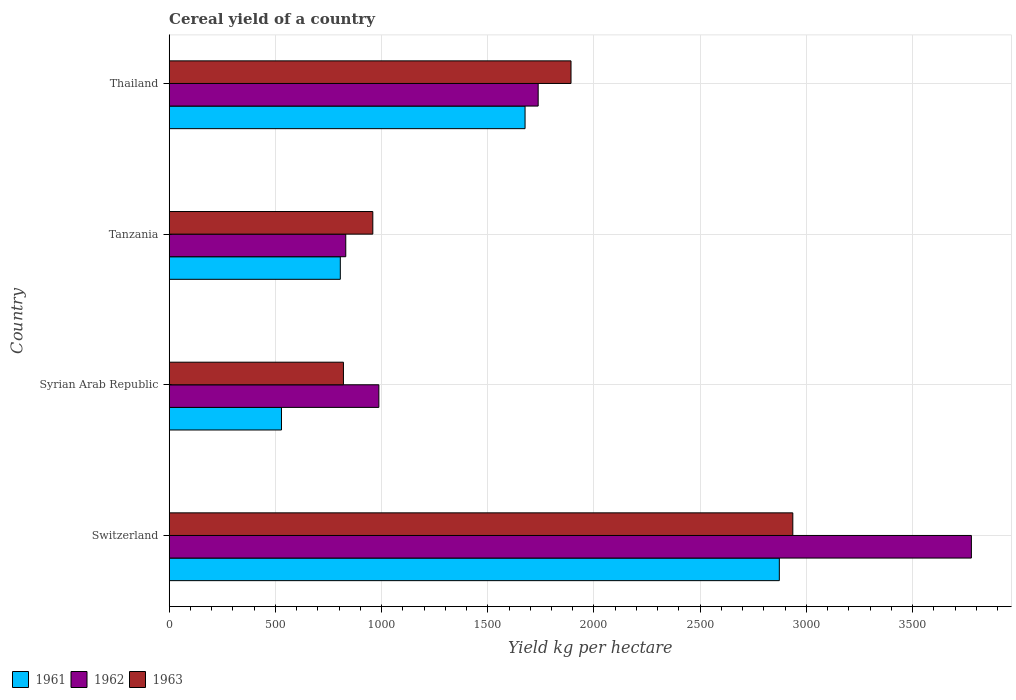How many groups of bars are there?
Provide a short and direct response. 4. Are the number of bars per tick equal to the number of legend labels?
Provide a short and direct response. Yes. Are the number of bars on each tick of the Y-axis equal?
Give a very brief answer. Yes. How many bars are there on the 3rd tick from the bottom?
Provide a short and direct response. 3. What is the label of the 4th group of bars from the top?
Keep it short and to the point. Switzerland. In how many cases, is the number of bars for a given country not equal to the number of legend labels?
Keep it short and to the point. 0. What is the total cereal yield in 1961 in Syrian Arab Republic?
Provide a short and direct response. 528.63. Across all countries, what is the maximum total cereal yield in 1961?
Your answer should be very brief. 2872.6. Across all countries, what is the minimum total cereal yield in 1963?
Make the answer very short. 820.32. In which country was the total cereal yield in 1963 maximum?
Keep it short and to the point. Switzerland. In which country was the total cereal yield in 1963 minimum?
Provide a short and direct response. Syrian Arab Republic. What is the total total cereal yield in 1962 in the graph?
Provide a short and direct response. 7332.44. What is the difference between the total cereal yield in 1963 in Syrian Arab Republic and that in Thailand?
Offer a very short reply. -1071.49. What is the difference between the total cereal yield in 1961 in Syrian Arab Republic and the total cereal yield in 1963 in Tanzania?
Make the answer very short. -430.02. What is the average total cereal yield in 1963 per country?
Your response must be concise. 1651.72. What is the difference between the total cereal yield in 1961 and total cereal yield in 1963 in Tanzania?
Offer a very short reply. -152.99. In how many countries, is the total cereal yield in 1961 greater than 300 kg per hectare?
Provide a succinct answer. 4. What is the ratio of the total cereal yield in 1962 in Switzerland to that in Thailand?
Offer a very short reply. 2.17. Is the total cereal yield in 1962 in Tanzania less than that in Thailand?
Your response must be concise. Yes. What is the difference between the highest and the second highest total cereal yield in 1962?
Give a very brief answer. 2039.65. What is the difference between the highest and the lowest total cereal yield in 1962?
Your answer should be compact. 2945.61. In how many countries, is the total cereal yield in 1963 greater than the average total cereal yield in 1963 taken over all countries?
Ensure brevity in your answer.  2. What does the 1st bar from the bottom in Syrian Arab Republic represents?
Your response must be concise. 1961. What is the difference between two consecutive major ticks on the X-axis?
Offer a very short reply. 500. Does the graph contain any zero values?
Provide a short and direct response. No. How many legend labels are there?
Offer a very short reply. 3. What is the title of the graph?
Make the answer very short. Cereal yield of a country. What is the label or title of the X-axis?
Make the answer very short. Yield kg per hectare. What is the label or title of the Y-axis?
Provide a short and direct response. Country. What is the Yield kg per hectare in 1961 in Switzerland?
Your answer should be very brief. 2872.6. What is the Yield kg per hectare of 1962 in Switzerland?
Your response must be concise. 3776.88. What is the Yield kg per hectare of 1963 in Switzerland?
Provide a short and direct response. 2936.11. What is the Yield kg per hectare of 1961 in Syrian Arab Republic?
Give a very brief answer. 528.63. What is the Yield kg per hectare in 1962 in Syrian Arab Republic?
Provide a succinct answer. 987.09. What is the Yield kg per hectare of 1963 in Syrian Arab Republic?
Provide a short and direct response. 820.32. What is the Yield kg per hectare in 1961 in Tanzania?
Offer a terse response. 805.65. What is the Yield kg per hectare of 1962 in Tanzania?
Your answer should be very brief. 831.26. What is the Yield kg per hectare in 1963 in Tanzania?
Your answer should be compact. 958.64. What is the Yield kg per hectare in 1961 in Thailand?
Ensure brevity in your answer.  1675.48. What is the Yield kg per hectare in 1962 in Thailand?
Ensure brevity in your answer.  1737.22. What is the Yield kg per hectare of 1963 in Thailand?
Make the answer very short. 1891.81. Across all countries, what is the maximum Yield kg per hectare in 1961?
Ensure brevity in your answer.  2872.6. Across all countries, what is the maximum Yield kg per hectare in 1962?
Make the answer very short. 3776.88. Across all countries, what is the maximum Yield kg per hectare of 1963?
Your response must be concise. 2936.11. Across all countries, what is the minimum Yield kg per hectare of 1961?
Give a very brief answer. 528.63. Across all countries, what is the minimum Yield kg per hectare of 1962?
Make the answer very short. 831.26. Across all countries, what is the minimum Yield kg per hectare of 1963?
Provide a succinct answer. 820.32. What is the total Yield kg per hectare of 1961 in the graph?
Your answer should be compact. 5882.36. What is the total Yield kg per hectare of 1962 in the graph?
Keep it short and to the point. 7332.44. What is the total Yield kg per hectare in 1963 in the graph?
Provide a succinct answer. 6606.88. What is the difference between the Yield kg per hectare of 1961 in Switzerland and that in Syrian Arab Republic?
Provide a succinct answer. 2343.97. What is the difference between the Yield kg per hectare in 1962 in Switzerland and that in Syrian Arab Republic?
Your answer should be very brief. 2789.79. What is the difference between the Yield kg per hectare in 1963 in Switzerland and that in Syrian Arab Republic?
Ensure brevity in your answer.  2115.79. What is the difference between the Yield kg per hectare of 1961 in Switzerland and that in Tanzania?
Make the answer very short. 2066.95. What is the difference between the Yield kg per hectare of 1962 in Switzerland and that in Tanzania?
Offer a very short reply. 2945.61. What is the difference between the Yield kg per hectare in 1963 in Switzerland and that in Tanzania?
Your response must be concise. 1977.47. What is the difference between the Yield kg per hectare of 1961 in Switzerland and that in Thailand?
Offer a terse response. 1197.11. What is the difference between the Yield kg per hectare of 1962 in Switzerland and that in Thailand?
Your response must be concise. 2039.65. What is the difference between the Yield kg per hectare in 1963 in Switzerland and that in Thailand?
Ensure brevity in your answer.  1044.3. What is the difference between the Yield kg per hectare in 1961 in Syrian Arab Republic and that in Tanzania?
Keep it short and to the point. -277.02. What is the difference between the Yield kg per hectare of 1962 in Syrian Arab Republic and that in Tanzania?
Provide a short and direct response. 155.82. What is the difference between the Yield kg per hectare in 1963 in Syrian Arab Republic and that in Tanzania?
Ensure brevity in your answer.  -138.33. What is the difference between the Yield kg per hectare of 1961 in Syrian Arab Republic and that in Thailand?
Provide a short and direct response. -1146.86. What is the difference between the Yield kg per hectare in 1962 in Syrian Arab Republic and that in Thailand?
Your answer should be compact. -750.14. What is the difference between the Yield kg per hectare in 1963 in Syrian Arab Republic and that in Thailand?
Offer a very short reply. -1071.49. What is the difference between the Yield kg per hectare of 1961 in Tanzania and that in Thailand?
Provide a succinct answer. -869.83. What is the difference between the Yield kg per hectare in 1962 in Tanzania and that in Thailand?
Make the answer very short. -905.96. What is the difference between the Yield kg per hectare in 1963 in Tanzania and that in Thailand?
Provide a succinct answer. -933.17. What is the difference between the Yield kg per hectare of 1961 in Switzerland and the Yield kg per hectare of 1962 in Syrian Arab Republic?
Make the answer very short. 1885.51. What is the difference between the Yield kg per hectare of 1961 in Switzerland and the Yield kg per hectare of 1963 in Syrian Arab Republic?
Make the answer very short. 2052.28. What is the difference between the Yield kg per hectare of 1962 in Switzerland and the Yield kg per hectare of 1963 in Syrian Arab Republic?
Provide a short and direct response. 2956.56. What is the difference between the Yield kg per hectare in 1961 in Switzerland and the Yield kg per hectare in 1962 in Tanzania?
Give a very brief answer. 2041.34. What is the difference between the Yield kg per hectare of 1961 in Switzerland and the Yield kg per hectare of 1963 in Tanzania?
Ensure brevity in your answer.  1913.95. What is the difference between the Yield kg per hectare of 1962 in Switzerland and the Yield kg per hectare of 1963 in Tanzania?
Offer a terse response. 2818.23. What is the difference between the Yield kg per hectare of 1961 in Switzerland and the Yield kg per hectare of 1962 in Thailand?
Your answer should be very brief. 1135.38. What is the difference between the Yield kg per hectare in 1961 in Switzerland and the Yield kg per hectare in 1963 in Thailand?
Provide a succinct answer. 980.79. What is the difference between the Yield kg per hectare of 1962 in Switzerland and the Yield kg per hectare of 1963 in Thailand?
Your answer should be compact. 1885.06. What is the difference between the Yield kg per hectare of 1961 in Syrian Arab Republic and the Yield kg per hectare of 1962 in Tanzania?
Give a very brief answer. -302.63. What is the difference between the Yield kg per hectare of 1961 in Syrian Arab Republic and the Yield kg per hectare of 1963 in Tanzania?
Provide a succinct answer. -430.02. What is the difference between the Yield kg per hectare of 1962 in Syrian Arab Republic and the Yield kg per hectare of 1963 in Tanzania?
Keep it short and to the point. 28.44. What is the difference between the Yield kg per hectare in 1961 in Syrian Arab Republic and the Yield kg per hectare in 1962 in Thailand?
Ensure brevity in your answer.  -1208.6. What is the difference between the Yield kg per hectare of 1961 in Syrian Arab Republic and the Yield kg per hectare of 1963 in Thailand?
Your answer should be compact. -1363.18. What is the difference between the Yield kg per hectare in 1962 in Syrian Arab Republic and the Yield kg per hectare in 1963 in Thailand?
Your response must be concise. -904.73. What is the difference between the Yield kg per hectare in 1961 in Tanzania and the Yield kg per hectare in 1962 in Thailand?
Offer a terse response. -931.57. What is the difference between the Yield kg per hectare of 1961 in Tanzania and the Yield kg per hectare of 1963 in Thailand?
Make the answer very short. -1086.16. What is the difference between the Yield kg per hectare in 1962 in Tanzania and the Yield kg per hectare in 1963 in Thailand?
Provide a short and direct response. -1060.55. What is the average Yield kg per hectare in 1961 per country?
Your answer should be very brief. 1470.59. What is the average Yield kg per hectare of 1962 per country?
Make the answer very short. 1833.11. What is the average Yield kg per hectare in 1963 per country?
Provide a succinct answer. 1651.72. What is the difference between the Yield kg per hectare of 1961 and Yield kg per hectare of 1962 in Switzerland?
Your response must be concise. -904.28. What is the difference between the Yield kg per hectare in 1961 and Yield kg per hectare in 1963 in Switzerland?
Your response must be concise. -63.51. What is the difference between the Yield kg per hectare in 1962 and Yield kg per hectare in 1963 in Switzerland?
Keep it short and to the point. 840.76. What is the difference between the Yield kg per hectare in 1961 and Yield kg per hectare in 1962 in Syrian Arab Republic?
Make the answer very short. -458.46. What is the difference between the Yield kg per hectare in 1961 and Yield kg per hectare in 1963 in Syrian Arab Republic?
Give a very brief answer. -291.69. What is the difference between the Yield kg per hectare of 1962 and Yield kg per hectare of 1963 in Syrian Arab Republic?
Make the answer very short. 166.77. What is the difference between the Yield kg per hectare of 1961 and Yield kg per hectare of 1962 in Tanzania?
Provide a short and direct response. -25.61. What is the difference between the Yield kg per hectare of 1961 and Yield kg per hectare of 1963 in Tanzania?
Provide a succinct answer. -152.99. What is the difference between the Yield kg per hectare of 1962 and Yield kg per hectare of 1963 in Tanzania?
Offer a very short reply. -127.38. What is the difference between the Yield kg per hectare of 1961 and Yield kg per hectare of 1962 in Thailand?
Make the answer very short. -61.74. What is the difference between the Yield kg per hectare of 1961 and Yield kg per hectare of 1963 in Thailand?
Provide a succinct answer. -216.33. What is the difference between the Yield kg per hectare of 1962 and Yield kg per hectare of 1963 in Thailand?
Keep it short and to the point. -154.59. What is the ratio of the Yield kg per hectare in 1961 in Switzerland to that in Syrian Arab Republic?
Ensure brevity in your answer.  5.43. What is the ratio of the Yield kg per hectare in 1962 in Switzerland to that in Syrian Arab Republic?
Offer a very short reply. 3.83. What is the ratio of the Yield kg per hectare of 1963 in Switzerland to that in Syrian Arab Republic?
Provide a short and direct response. 3.58. What is the ratio of the Yield kg per hectare in 1961 in Switzerland to that in Tanzania?
Provide a short and direct response. 3.57. What is the ratio of the Yield kg per hectare of 1962 in Switzerland to that in Tanzania?
Make the answer very short. 4.54. What is the ratio of the Yield kg per hectare in 1963 in Switzerland to that in Tanzania?
Your answer should be very brief. 3.06. What is the ratio of the Yield kg per hectare in 1961 in Switzerland to that in Thailand?
Offer a terse response. 1.71. What is the ratio of the Yield kg per hectare in 1962 in Switzerland to that in Thailand?
Provide a succinct answer. 2.17. What is the ratio of the Yield kg per hectare in 1963 in Switzerland to that in Thailand?
Ensure brevity in your answer.  1.55. What is the ratio of the Yield kg per hectare of 1961 in Syrian Arab Republic to that in Tanzania?
Your answer should be compact. 0.66. What is the ratio of the Yield kg per hectare of 1962 in Syrian Arab Republic to that in Tanzania?
Offer a very short reply. 1.19. What is the ratio of the Yield kg per hectare in 1963 in Syrian Arab Republic to that in Tanzania?
Offer a terse response. 0.86. What is the ratio of the Yield kg per hectare of 1961 in Syrian Arab Republic to that in Thailand?
Your response must be concise. 0.32. What is the ratio of the Yield kg per hectare of 1962 in Syrian Arab Republic to that in Thailand?
Your answer should be very brief. 0.57. What is the ratio of the Yield kg per hectare of 1963 in Syrian Arab Republic to that in Thailand?
Ensure brevity in your answer.  0.43. What is the ratio of the Yield kg per hectare in 1961 in Tanzania to that in Thailand?
Your response must be concise. 0.48. What is the ratio of the Yield kg per hectare in 1962 in Tanzania to that in Thailand?
Your answer should be compact. 0.48. What is the ratio of the Yield kg per hectare of 1963 in Tanzania to that in Thailand?
Your answer should be compact. 0.51. What is the difference between the highest and the second highest Yield kg per hectare in 1961?
Give a very brief answer. 1197.11. What is the difference between the highest and the second highest Yield kg per hectare of 1962?
Keep it short and to the point. 2039.65. What is the difference between the highest and the second highest Yield kg per hectare of 1963?
Ensure brevity in your answer.  1044.3. What is the difference between the highest and the lowest Yield kg per hectare of 1961?
Offer a very short reply. 2343.97. What is the difference between the highest and the lowest Yield kg per hectare in 1962?
Ensure brevity in your answer.  2945.61. What is the difference between the highest and the lowest Yield kg per hectare in 1963?
Ensure brevity in your answer.  2115.79. 